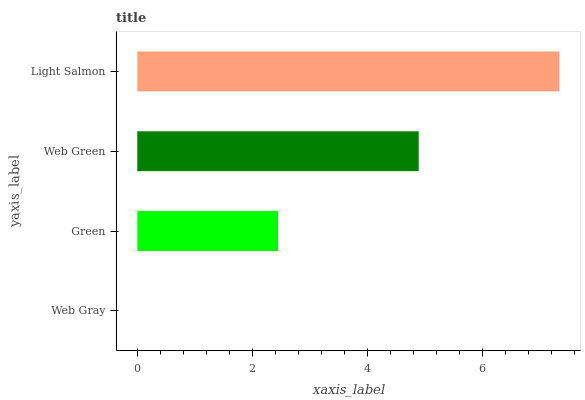Is Web Gray the minimum?
Answer yes or no. Yes. Is Light Salmon the maximum?
Answer yes or no. Yes. Is Green the minimum?
Answer yes or no. No. Is Green the maximum?
Answer yes or no. No. Is Green greater than Web Gray?
Answer yes or no. Yes. Is Web Gray less than Green?
Answer yes or no. Yes. Is Web Gray greater than Green?
Answer yes or no. No. Is Green less than Web Gray?
Answer yes or no. No. Is Web Green the high median?
Answer yes or no. Yes. Is Green the low median?
Answer yes or no. Yes. Is Green the high median?
Answer yes or no. No. Is Web Green the low median?
Answer yes or no. No. 